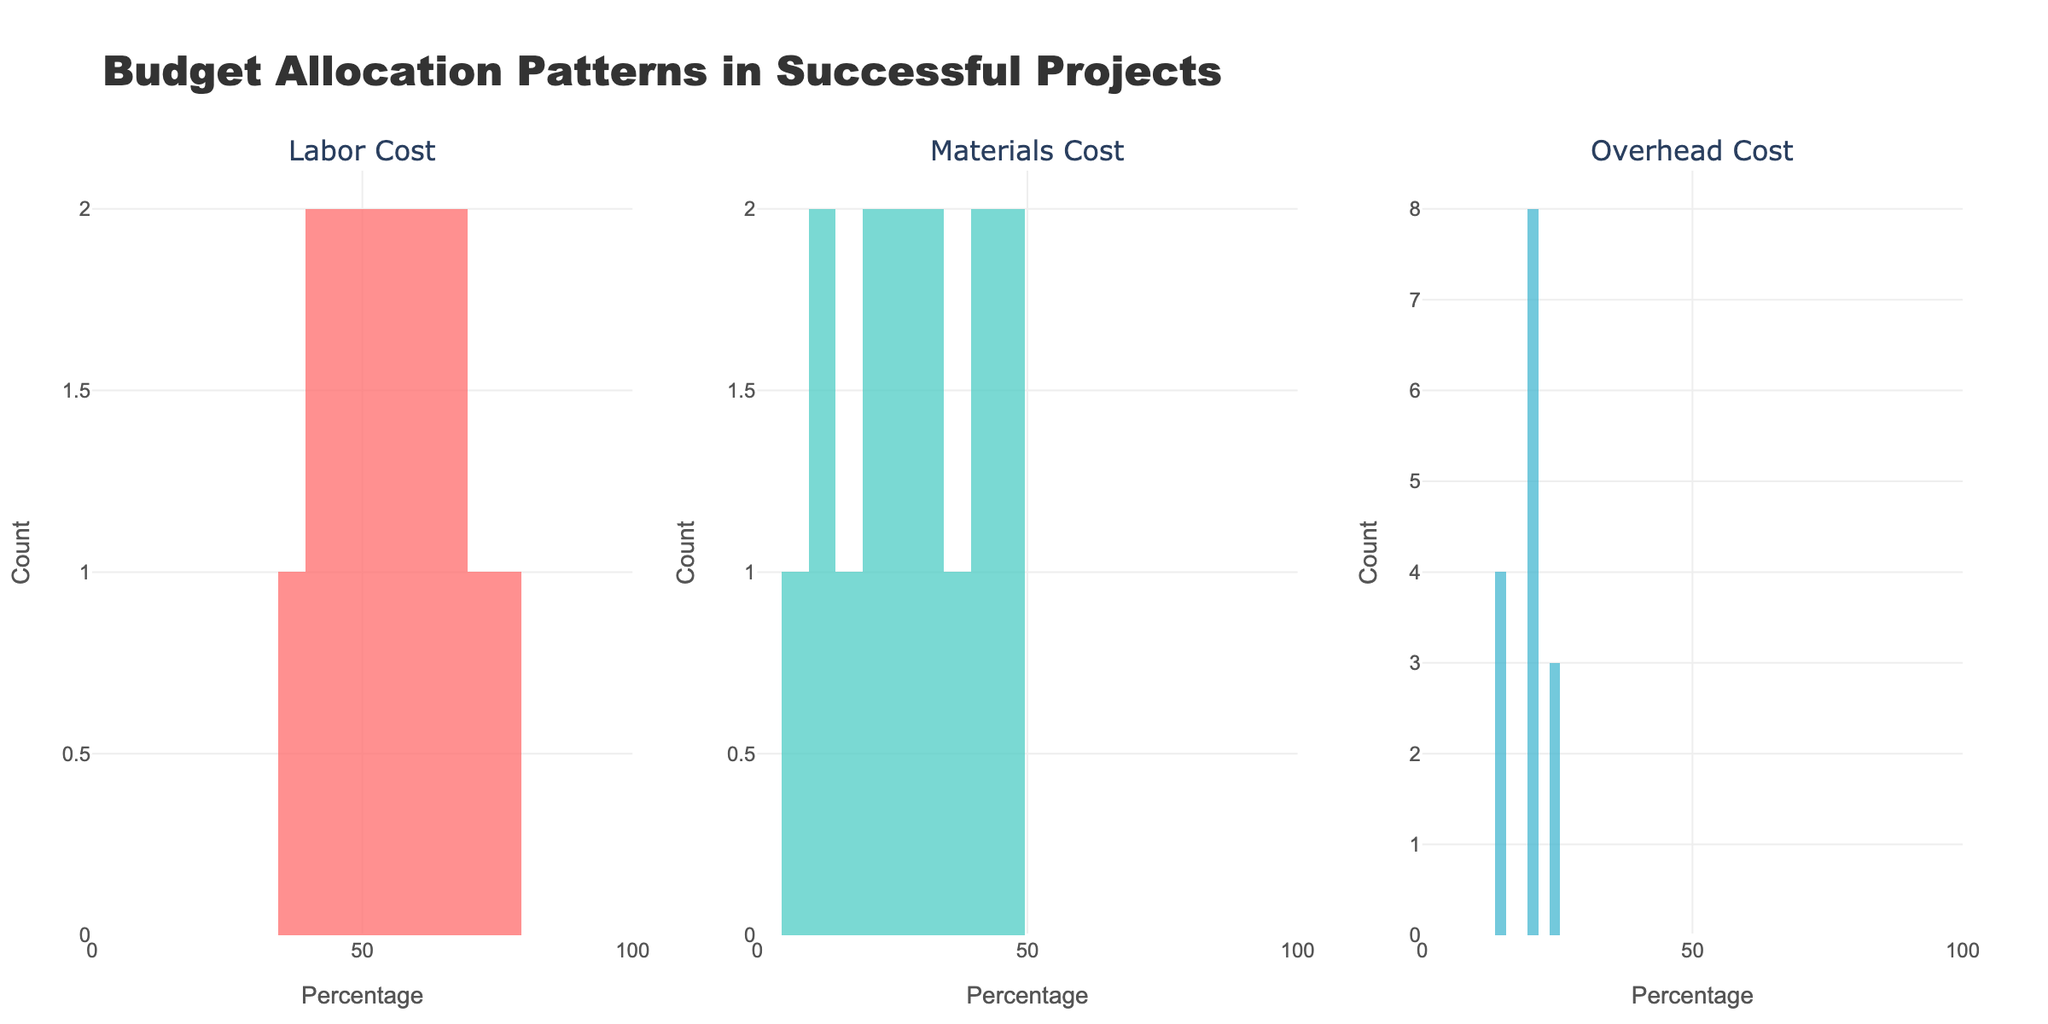What is the title of the figure? The title of the figure is usually placed at the top of the chart. This particular figure has a title that describes the content about budget allocation patterns in successful projects.
Answer: Budget Allocation Patterns in Successful Projects What are the three cost types represented in the subplots? Each subplot has a title indicating the cost type. By looking at these titles, we can identify the three cost types.
Answer: Labor Cost, Materials Cost, Overhead Cost Which cost type seems to have the highest concentration of projects with costs between 50% and 60%? By examining the histograms, we see which cost type has the tallest bars within the 50%-60% range.
Answer: Labor Cost How many projects allocate around 20% of their budget to materials? Look at the second subplot (Materials Cost) and count the number of bars above the 20% mark.
Answer: 2 projects Which cost type has the broadest distribution of budget allocation percentages? Examine the spread of the bars across the x-axis in each subplot and see which one occupies the widest range.
Answer: Materials Cost What's the average budget allocation for labor costs among the projects? Summing up all the percentages in the Labor Cost histogram and then dividing by the number of projects gives the average labor cost allocation.
Answer: (45+60+55+50+40+65+45+70+55+50+65+35+75+60+40)/15 = 54.33% Is there any cost type where no projects allocated more than 75%? Check each histogram to see if any bars go beyond the 75% mark. Identify the cost type with no bars extending past this point.
Answer: Materials Cost, Overhead Cost How does the distribution of overhead costs compare to the distribution of labor costs? Compare the distribution shapes of both histograms. Note the range and peak areas.
Answer: Overhead costs are more evenly distributed, while labor costs peak heavily around 50%-60% Are there any cost types where multiple projects allocated exactly the same percentage? If yes, which one? Check each histogram carefully to see if any bar heights indicate multiple projects allocating the same exact percentage.
Answer: Yes, Labor Cost (60%; 55%), Materials Cost (30%) What is the count of projects that allocated the least percentage to overhead costs? Locate the smallest percentage on the overhead cost histogram and count the number of projects represented by the bar at that percentage.
Answer: 1 project 